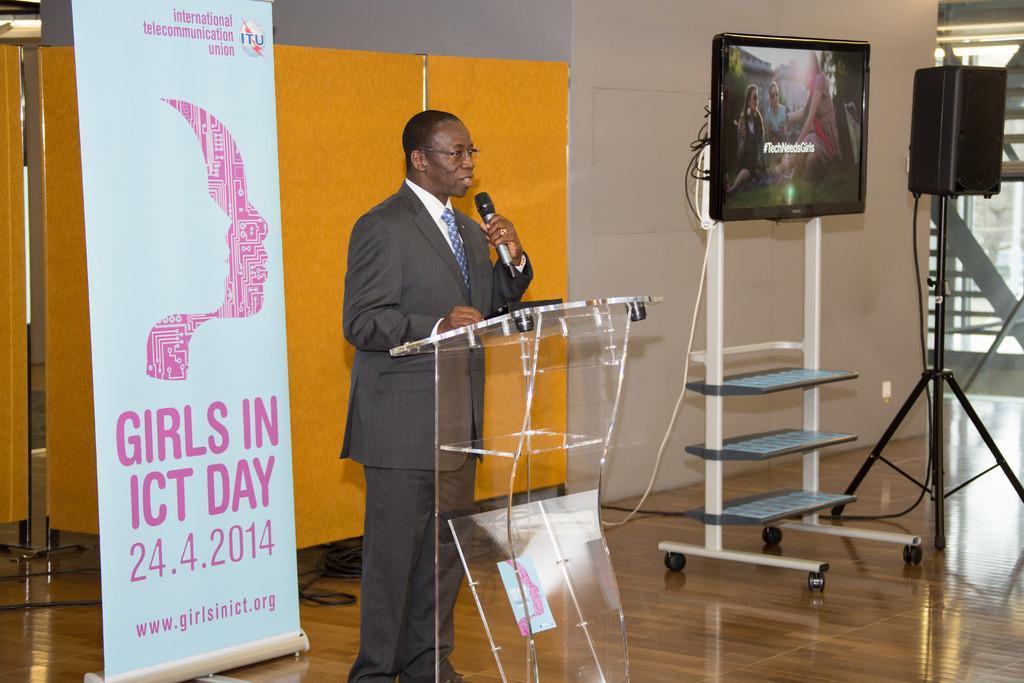Could you give a brief overview of what you see in this image? In this image there is a man with a suit standing in front of the podium and holding a mike. In the background there is a yellow color wall. On the left there is a hoarding present on the floor and on the right there is a television and also a speaker with a stand. 